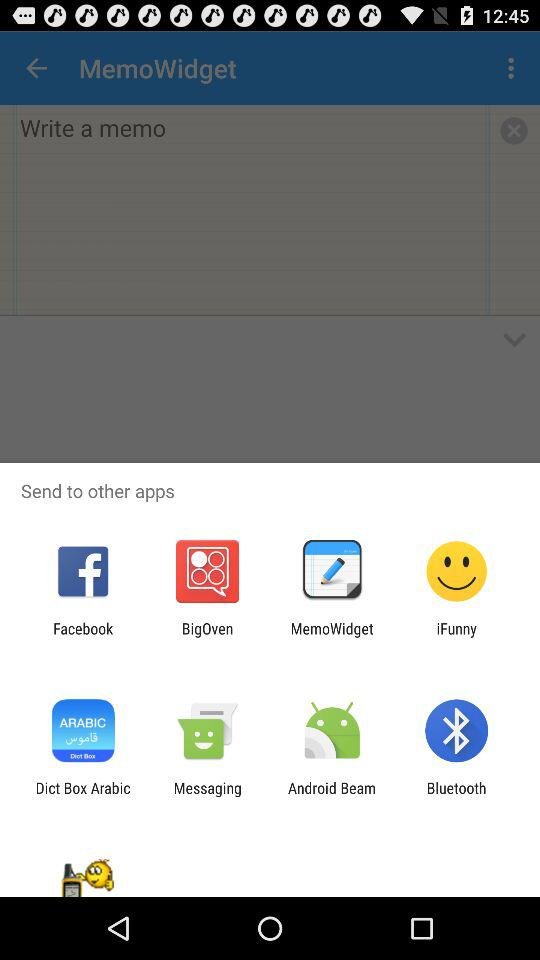What are the apps that may be used to share memos? The apps are "Facebook", "BigOven", "MemoWidget", "iFunny", "Dict Box Arabic", "Messaging", "Android" and "Bluetooth". 